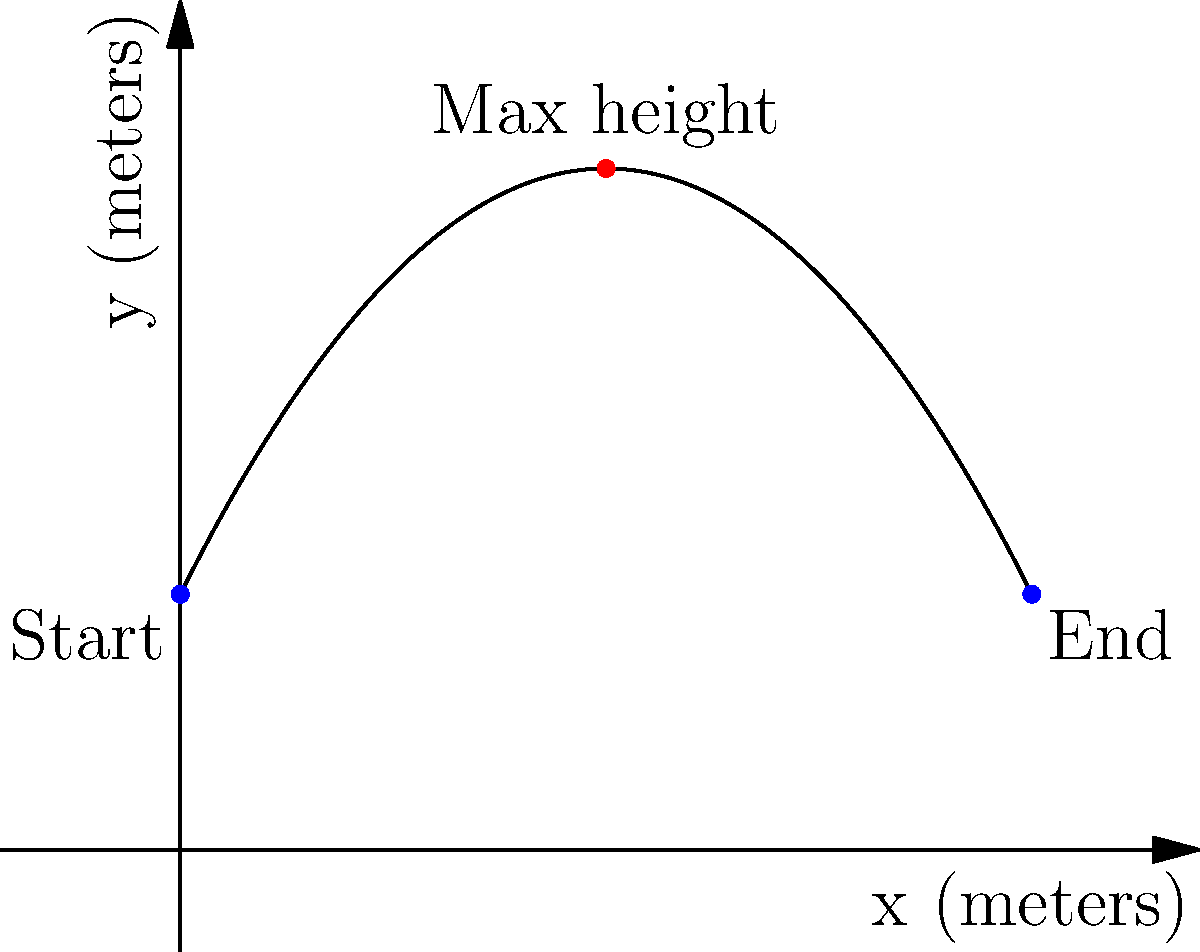During a vault jump, your trajectory follows a parabolic path described by the equation $y = -0.2x^2 + 2x + 3$, where $x$ and $y$ are measured in meters. If your jump starts at $x = 0$ and ends at $x = 10$, what is the maximum height you reach during the jump? To find the maximum height of the parabolic trajectory, we need to follow these steps:

1) The equation of the trajectory is $y = -0.2x^2 + 2x + 3$

2) To find the maximum point, we need to find the vertex of the parabola. For a quadratic function in the form $y = ax^2 + bx + c$, the x-coordinate of the vertex is given by $x = -\frac{b}{2a}$

3) In our equation, $a = -0.2$ and $b = 2$. So:

   $x = -\frac{2}{2(-0.2)} = -\frac{2}{-0.4} = 5$

4) To find the y-coordinate (the maximum height), we substitute this x-value back into the original equation:

   $y = -0.2(5)^2 + 2(5) + 3$
   $= -0.2(25) + 10 + 3$
   $= -5 + 10 + 3$
   $= 8$

5) Therefore, the maximum point of the trajectory is at (5, 8).

The maximum height reached during the jump is 8 meters.
Answer: 8 meters 